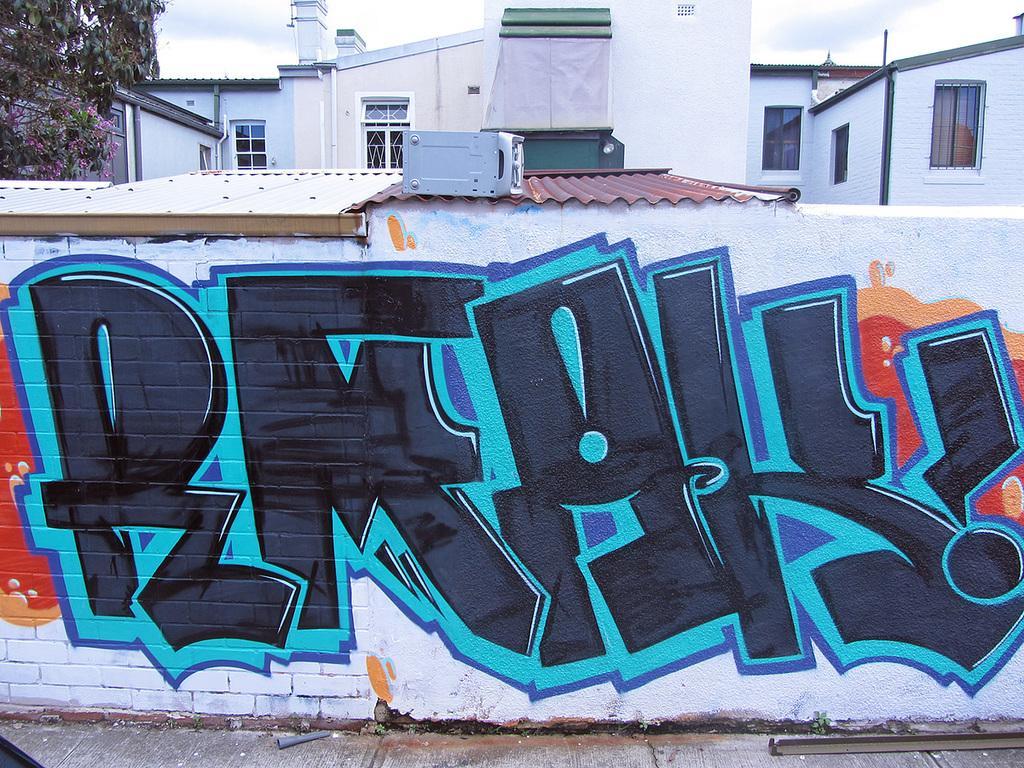How would you summarize this image in a sentence or two? In the image there is a wall with graffiti. And also there are roofs with a machine on it. In the background there are buildings with walls, windows and roofs. In the top left corner of the image there are leaves with flowers. At the top of the image in the background there is sky 